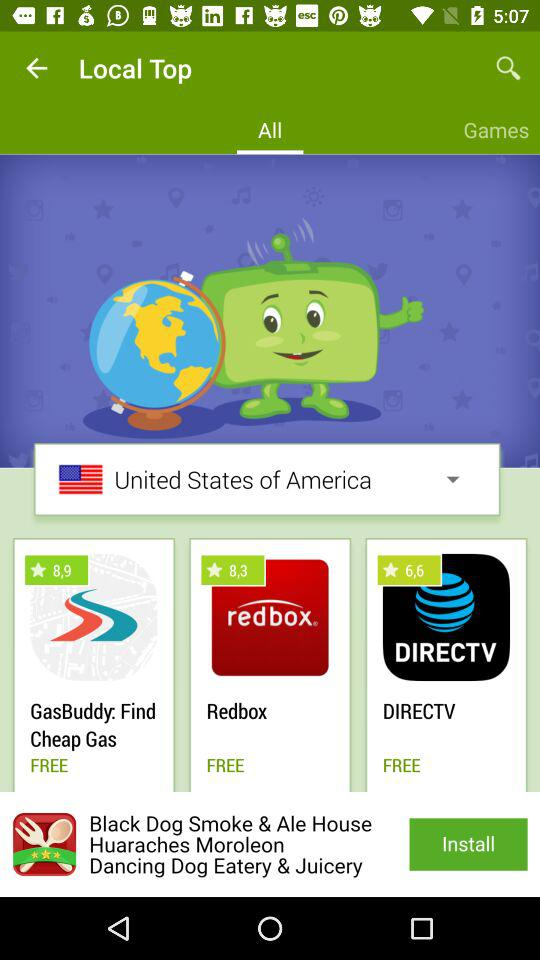What is the rating for "DIRECTV"? The rating for "DIRECTV" is 6.6 stars. 